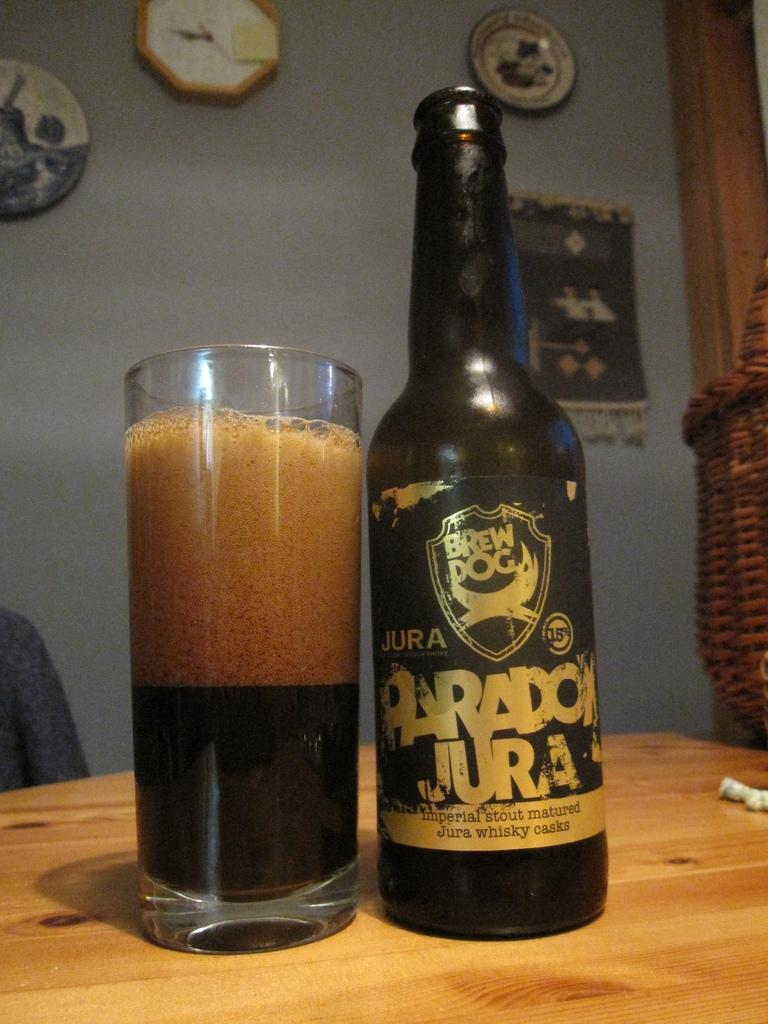Provide a one-sentence caption for the provided image. A wooden table with a drinking glass and a bottle of Paradox Jura  whiskey. 